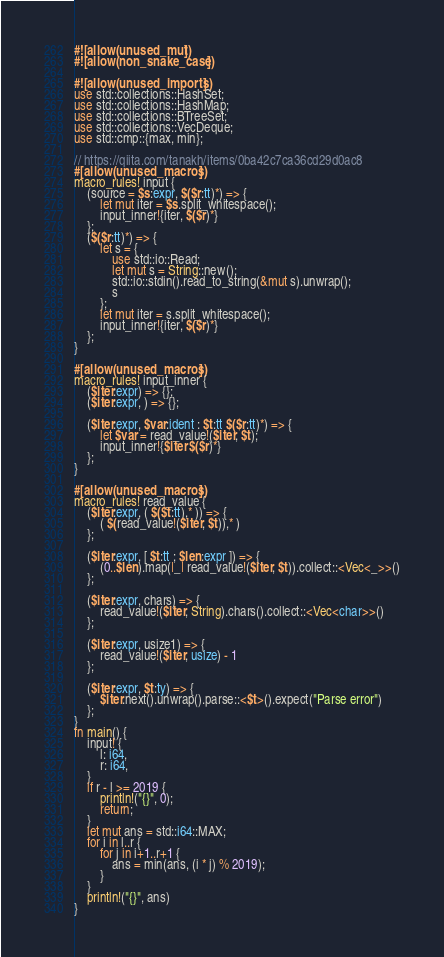Convert code to text. <code><loc_0><loc_0><loc_500><loc_500><_Rust_>#![allow(unused_mut)]
#![allow(non_snake_case)]

#![allow(unused_imports)]
use std::collections::HashSet;
use std::collections::HashMap;
use std::collections::BTreeSet;
use std::collections::VecDeque;
use std::cmp::{max, min};

// https://qiita.com/tanakh/items/0ba42c7ca36cd29d0ac8
#[allow(unused_macros)]
macro_rules! input {
    (source = $s:expr, $($r:tt)*) => {
        let mut iter = $s.split_whitespace();
        input_inner!{iter, $($r)*}
    };
    ($($r:tt)*) => {
        let s = {
            use std::io::Read;
            let mut s = String::new();
            std::io::stdin().read_to_string(&mut s).unwrap();
            s
        };
        let mut iter = s.split_whitespace();
        input_inner!{iter, $($r)*}
    };
}

#[allow(unused_macros)]
macro_rules! input_inner {
    ($iter:expr) => {};
    ($iter:expr, ) => {};

    ($iter:expr, $var:ident : $t:tt $($r:tt)*) => {
        let $var = read_value!($iter, $t);
        input_inner!{$iter $($r)*}
    };
}

#[allow(unused_macros)]
macro_rules! read_value {
    ($iter:expr, ( $($t:tt),* )) => {
        ( $(read_value!($iter, $t)),* )
    };

    ($iter:expr, [ $t:tt ; $len:expr ]) => {
        (0..$len).map(|_| read_value!($iter, $t)).collect::<Vec<_>>()
    };

    ($iter:expr, chars) => {
        read_value!($iter, String).chars().collect::<Vec<char>>()
    };

    ($iter:expr, usize1) => {
        read_value!($iter, usize) - 1
    };

    ($iter:expr, $t:ty) => {
        $iter.next().unwrap().parse::<$t>().expect("Parse error")
    };
}
fn main() {
    input! {
        l: i64,
        r: i64,
    }
    if r - l >= 2019 {
        println!("{}", 0);
        return;
    }
    let mut ans = std::i64::MAX;
    for i in l..r {
        for j in i+1..r+1 {
            ans = min(ans, (i * j) % 2019);
        }
    }
    println!("{}", ans)
}</code> 